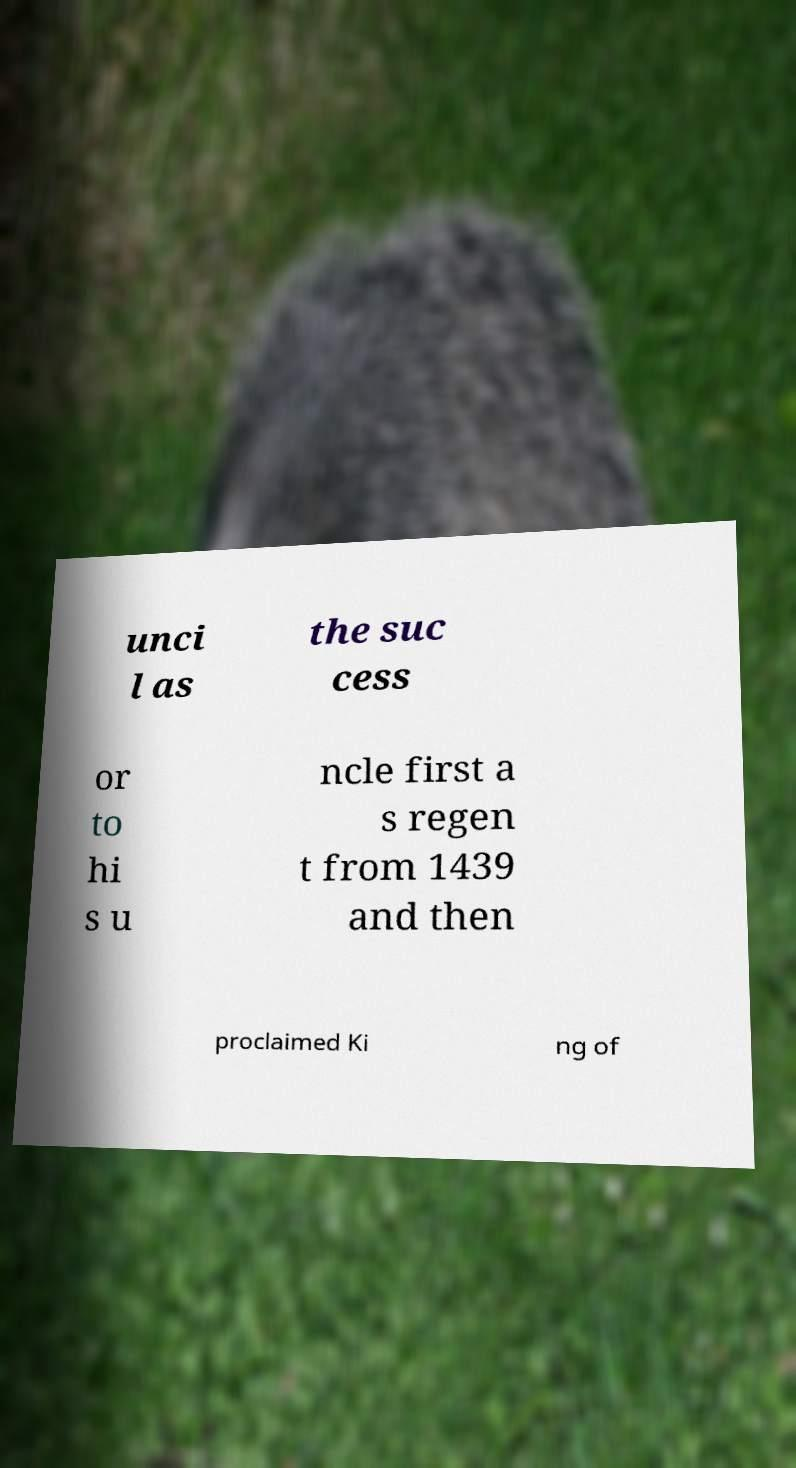Please read and relay the text visible in this image. What does it say? unci l as the suc cess or to hi s u ncle first a s regen t from 1439 and then proclaimed Ki ng of 